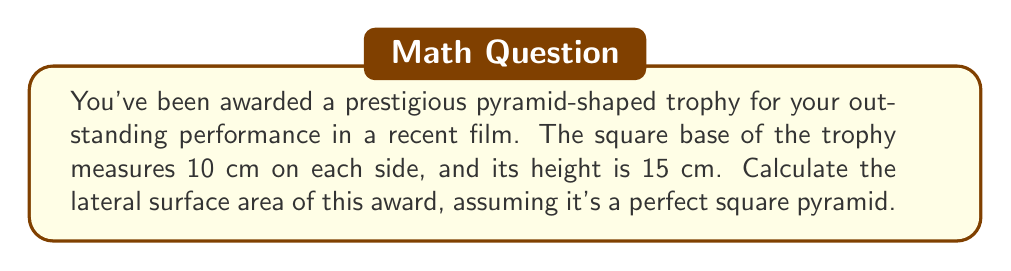Help me with this question. To calculate the lateral surface area of a square pyramid, we need to follow these steps:

1. Determine the slant height of the pyramid:
   The slant height (s) is the distance from the apex to the middle of any side of the base.
   We can find this using the Pythagorean theorem:

   $$s^2 = h^2 + (\frac{a}{2})^2$$

   Where h is the height of the pyramid and a is the side length of the base.

   $$s^2 = 15^2 + 5^2 = 225 + 25 = 250$$
   $$s = \sqrt{250} = 5\sqrt{10} \approx 15.81 \text{ cm}$$

2. Calculate the area of one triangular face:
   The area of a triangle is given by $\frac{1}{2} \times base \times height$
   In this case, the base is the side of the square (10 cm), and the height is the slant height we just calculated.

   $$A_{face} = \frac{1}{2} \times 10 \times 5\sqrt{10} = 25\sqrt{10} \text{ cm}^2$$

3. Multiply the area of one face by 4 to get the total lateral surface area:
   Since there are four identical triangular faces, we multiply the area of one face by 4.

   $$A_{lateral} = 4 \times 25\sqrt{10} = 100\sqrt{10} \text{ cm}^2$$

[asy]
import geometry;

size(200);
pair A = (0,0), B = (4,0), C = (4,4), D = (0,4), E = (2,6);
draw(A--B--C--D--cycle);
draw(A--E--C);
draw(B--E);
draw(D--E,dashed);
label("15 cm", (2,3), E);
label("10 cm", (2,0), S);
[/asy]
Answer: $100\sqrt{10} \text{ cm}^2$ 